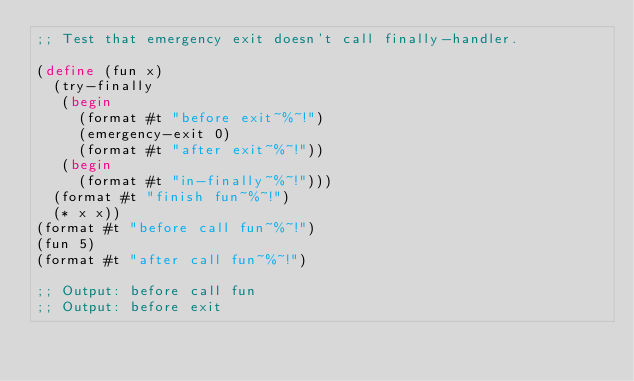<code> <loc_0><loc_0><loc_500><loc_500><_Scheme_>;; Test that emergency exit doesn't call finally-handler.

(define (fun x)
  (try-finally
   (begin
     (format #t "before exit~%~!")
     (emergency-exit 0)
     (format #t "after exit~%~!"))
   (begin
     (format #t "in-finally~%~!")))
  (format #t "finish fun~%~!")
  (* x x))
(format #t "before call fun~%~!")
(fun 5)
(format #t "after call fun~%~!")

;; Output: before call fun
;; Output: before exit
</code> 